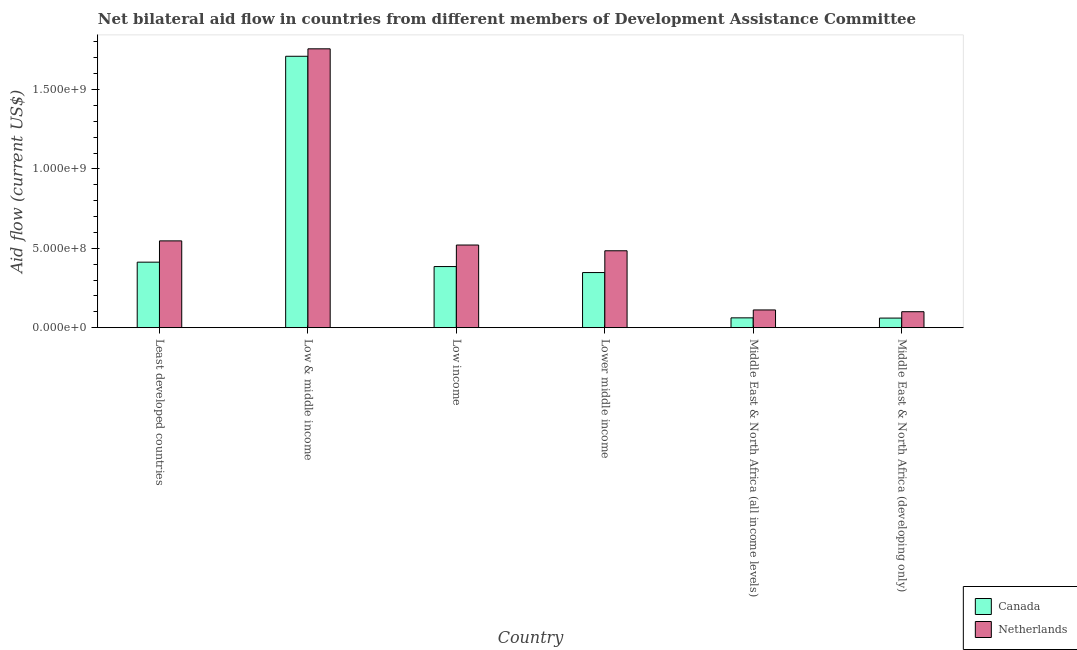How many different coloured bars are there?
Offer a very short reply. 2. Are the number of bars per tick equal to the number of legend labels?
Ensure brevity in your answer.  Yes. Are the number of bars on each tick of the X-axis equal?
Provide a short and direct response. Yes. What is the amount of aid given by netherlands in Low income?
Provide a succinct answer. 5.20e+08. Across all countries, what is the maximum amount of aid given by netherlands?
Your answer should be compact. 1.76e+09. Across all countries, what is the minimum amount of aid given by canada?
Offer a very short reply. 6.04e+07. In which country was the amount of aid given by canada maximum?
Make the answer very short. Low & middle income. In which country was the amount of aid given by netherlands minimum?
Make the answer very short. Middle East & North Africa (developing only). What is the total amount of aid given by canada in the graph?
Your response must be concise. 2.98e+09. What is the difference between the amount of aid given by canada in Least developed countries and that in Low & middle income?
Keep it short and to the point. -1.30e+09. What is the difference between the amount of aid given by netherlands in Low & middle income and the amount of aid given by canada in Middle East & North Africa (all income levels)?
Ensure brevity in your answer.  1.69e+09. What is the average amount of aid given by netherlands per country?
Your answer should be very brief. 5.87e+08. What is the difference between the amount of aid given by netherlands and amount of aid given by canada in Middle East & North Africa (all income levels)?
Your answer should be very brief. 4.98e+07. In how many countries, is the amount of aid given by canada greater than 1200000000 US$?
Your answer should be very brief. 1. What is the ratio of the amount of aid given by canada in Low income to that in Middle East & North Africa (all income levels)?
Give a very brief answer. 6.23. Is the amount of aid given by canada in Low & middle income less than that in Middle East & North Africa (all income levels)?
Provide a succinct answer. No. What is the difference between the highest and the second highest amount of aid given by canada?
Your answer should be compact. 1.30e+09. What is the difference between the highest and the lowest amount of aid given by canada?
Your response must be concise. 1.65e+09. In how many countries, is the amount of aid given by netherlands greater than the average amount of aid given by netherlands taken over all countries?
Your answer should be compact. 1. Is the sum of the amount of aid given by canada in Low income and Middle East & North Africa (all income levels) greater than the maximum amount of aid given by netherlands across all countries?
Provide a short and direct response. No. What does the 1st bar from the left in Least developed countries represents?
Provide a short and direct response. Canada. How many countries are there in the graph?
Provide a succinct answer. 6. What is the difference between two consecutive major ticks on the Y-axis?
Make the answer very short. 5.00e+08. Are the values on the major ticks of Y-axis written in scientific E-notation?
Make the answer very short. Yes. Does the graph contain any zero values?
Offer a very short reply. No. Where does the legend appear in the graph?
Offer a very short reply. Bottom right. What is the title of the graph?
Your answer should be very brief. Net bilateral aid flow in countries from different members of Development Assistance Committee. Does "Number of arrivals" appear as one of the legend labels in the graph?
Offer a terse response. No. What is the label or title of the X-axis?
Provide a succinct answer. Country. What is the label or title of the Y-axis?
Your answer should be compact. Aid flow (current US$). What is the Aid flow (current US$) in Canada in Least developed countries?
Your answer should be compact. 4.13e+08. What is the Aid flow (current US$) in Netherlands in Least developed countries?
Offer a very short reply. 5.47e+08. What is the Aid flow (current US$) of Canada in Low & middle income?
Ensure brevity in your answer.  1.71e+09. What is the Aid flow (current US$) in Netherlands in Low & middle income?
Your answer should be compact. 1.76e+09. What is the Aid flow (current US$) of Canada in Low income?
Ensure brevity in your answer.  3.85e+08. What is the Aid flow (current US$) of Netherlands in Low income?
Make the answer very short. 5.20e+08. What is the Aid flow (current US$) in Canada in Lower middle income?
Give a very brief answer. 3.47e+08. What is the Aid flow (current US$) in Netherlands in Lower middle income?
Provide a succinct answer. 4.84e+08. What is the Aid flow (current US$) in Canada in Middle East & North Africa (all income levels)?
Provide a short and direct response. 6.18e+07. What is the Aid flow (current US$) in Netherlands in Middle East & North Africa (all income levels)?
Give a very brief answer. 1.12e+08. What is the Aid flow (current US$) of Canada in Middle East & North Africa (developing only)?
Keep it short and to the point. 6.04e+07. What is the Aid flow (current US$) of Netherlands in Middle East & North Africa (developing only)?
Ensure brevity in your answer.  1.00e+08. Across all countries, what is the maximum Aid flow (current US$) in Canada?
Your answer should be very brief. 1.71e+09. Across all countries, what is the maximum Aid flow (current US$) in Netherlands?
Your answer should be very brief. 1.76e+09. Across all countries, what is the minimum Aid flow (current US$) of Canada?
Make the answer very short. 6.04e+07. Across all countries, what is the minimum Aid flow (current US$) of Netherlands?
Keep it short and to the point. 1.00e+08. What is the total Aid flow (current US$) of Canada in the graph?
Your answer should be compact. 2.98e+09. What is the total Aid flow (current US$) of Netherlands in the graph?
Your answer should be very brief. 3.52e+09. What is the difference between the Aid flow (current US$) of Canada in Least developed countries and that in Low & middle income?
Provide a succinct answer. -1.30e+09. What is the difference between the Aid flow (current US$) of Netherlands in Least developed countries and that in Low & middle income?
Your answer should be very brief. -1.21e+09. What is the difference between the Aid flow (current US$) of Canada in Least developed countries and that in Low income?
Offer a terse response. 2.77e+07. What is the difference between the Aid flow (current US$) in Netherlands in Least developed countries and that in Low income?
Offer a terse response. 2.61e+07. What is the difference between the Aid flow (current US$) of Canada in Least developed countries and that in Lower middle income?
Provide a succinct answer. 6.55e+07. What is the difference between the Aid flow (current US$) in Netherlands in Least developed countries and that in Lower middle income?
Your answer should be compact. 6.23e+07. What is the difference between the Aid flow (current US$) in Canada in Least developed countries and that in Middle East & North Africa (all income levels)?
Your answer should be compact. 3.51e+08. What is the difference between the Aid flow (current US$) in Netherlands in Least developed countries and that in Middle East & North Africa (all income levels)?
Provide a short and direct response. 4.35e+08. What is the difference between the Aid flow (current US$) in Canada in Least developed countries and that in Middle East & North Africa (developing only)?
Keep it short and to the point. 3.52e+08. What is the difference between the Aid flow (current US$) of Netherlands in Least developed countries and that in Middle East & North Africa (developing only)?
Give a very brief answer. 4.46e+08. What is the difference between the Aid flow (current US$) in Canada in Low & middle income and that in Low income?
Provide a succinct answer. 1.32e+09. What is the difference between the Aid flow (current US$) in Netherlands in Low & middle income and that in Low income?
Your answer should be compact. 1.24e+09. What is the difference between the Aid flow (current US$) of Canada in Low & middle income and that in Lower middle income?
Your response must be concise. 1.36e+09. What is the difference between the Aid flow (current US$) in Netherlands in Low & middle income and that in Lower middle income?
Provide a short and direct response. 1.27e+09. What is the difference between the Aid flow (current US$) of Canada in Low & middle income and that in Middle East & North Africa (all income levels)?
Your answer should be very brief. 1.65e+09. What is the difference between the Aid flow (current US$) of Netherlands in Low & middle income and that in Middle East & North Africa (all income levels)?
Keep it short and to the point. 1.64e+09. What is the difference between the Aid flow (current US$) in Canada in Low & middle income and that in Middle East & North Africa (developing only)?
Offer a very short reply. 1.65e+09. What is the difference between the Aid flow (current US$) in Netherlands in Low & middle income and that in Middle East & North Africa (developing only)?
Provide a succinct answer. 1.66e+09. What is the difference between the Aid flow (current US$) in Canada in Low income and that in Lower middle income?
Your response must be concise. 3.78e+07. What is the difference between the Aid flow (current US$) in Netherlands in Low income and that in Lower middle income?
Ensure brevity in your answer.  3.61e+07. What is the difference between the Aid flow (current US$) of Canada in Low income and that in Middle East & North Africa (all income levels)?
Offer a very short reply. 3.23e+08. What is the difference between the Aid flow (current US$) in Netherlands in Low income and that in Middle East & North Africa (all income levels)?
Offer a very short reply. 4.09e+08. What is the difference between the Aid flow (current US$) of Canada in Low income and that in Middle East & North Africa (developing only)?
Keep it short and to the point. 3.25e+08. What is the difference between the Aid flow (current US$) of Netherlands in Low income and that in Middle East & North Africa (developing only)?
Offer a very short reply. 4.20e+08. What is the difference between the Aid flow (current US$) in Canada in Lower middle income and that in Middle East & North Africa (all income levels)?
Your response must be concise. 2.85e+08. What is the difference between the Aid flow (current US$) in Netherlands in Lower middle income and that in Middle East & North Africa (all income levels)?
Offer a very short reply. 3.73e+08. What is the difference between the Aid flow (current US$) of Canada in Lower middle income and that in Middle East & North Africa (developing only)?
Give a very brief answer. 2.87e+08. What is the difference between the Aid flow (current US$) of Netherlands in Lower middle income and that in Middle East & North Africa (developing only)?
Offer a very short reply. 3.84e+08. What is the difference between the Aid flow (current US$) of Canada in Middle East & North Africa (all income levels) and that in Middle East & North Africa (developing only)?
Your response must be concise. 1.44e+06. What is the difference between the Aid flow (current US$) of Netherlands in Middle East & North Africa (all income levels) and that in Middle East & North Africa (developing only)?
Provide a succinct answer. 1.12e+07. What is the difference between the Aid flow (current US$) of Canada in Least developed countries and the Aid flow (current US$) of Netherlands in Low & middle income?
Your answer should be compact. -1.34e+09. What is the difference between the Aid flow (current US$) of Canada in Least developed countries and the Aid flow (current US$) of Netherlands in Low income?
Your answer should be compact. -1.08e+08. What is the difference between the Aid flow (current US$) in Canada in Least developed countries and the Aid flow (current US$) in Netherlands in Lower middle income?
Give a very brief answer. -7.17e+07. What is the difference between the Aid flow (current US$) of Canada in Least developed countries and the Aid flow (current US$) of Netherlands in Middle East & North Africa (all income levels)?
Your response must be concise. 3.01e+08. What is the difference between the Aid flow (current US$) of Canada in Least developed countries and the Aid flow (current US$) of Netherlands in Middle East & North Africa (developing only)?
Ensure brevity in your answer.  3.12e+08. What is the difference between the Aid flow (current US$) of Canada in Low & middle income and the Aid flow (current US$) of Netherlands in Low income?
Keep it short and to the point. 1.19e+09. What is the difference between the Aid flow (current US$) in Canada in Low & middle income and the Aid flow (current US$) in Netherlands in Lower middle income?
Your response must be concise. 1.22e+09. What is the difference between the Aid flow (current US$) of Canada in Low & middle income and the Aid flow (current US$) of Netherlands in Middle East & North Africa (all income levels)?
Keep it short and to the point. 1.60e+09. What is the difference between the Aid flow (current US$) of Canada in Low & middle income and the Aid flow (current US$) of Netherlands in Middle East & North Africa (developing only)?
Give a very brief answer. 1.61e+09. What is the difference between the Aid flow (current US$) of Canada in Low income and the Aid flow (current US$) of Netherlands in Lower middle income?
Your response must be concise. -9.94e+07. What is the difference between the Aid flow (current US$) in Canada in Low income and the Aid flow (current US$) in Netherlands in Middle East & North Africa (all income levels)?
Make the answer very short. 2.73e+08. What is the difference between the Aid flow (current US$) of Canada in Low income and the Aid flow (current US$) of Netherlands in Middle East & North Africa (developing only)?
Offer a terse response. 2.84e+08. What is the difference between the Aid flow (current US$) of Canada in Lower middle income and the Aid flow (current US$) of Netherlands in Middle East & North Africa (all income levels)?
Ensure brevity in your answer.  2.35e+08. What is the difference between the Aid flow (current US$) of Canada in Lower middle income and the Aid flow (current US$) of Netherlands in Middle East & North Africa (developing only)?
Your response must be concise. 2.47e+08. What is the difference between the Aid flow (current US$) of Canada in Middle East & North Africa (all income levels) and the Aid flow (current US$) of Netherlands in Middle East & North Africa (developing only)?
Ensure brevity in your answer.  -3.86e+07. What is the average Aid flow (current US$) of Canada per country?
Your response must be concise. 4.96e+08. What is the average Aid flow (current US$) in Netherlands per country?
Give a very brief answer. 5.87e+08. What is the difference between the Aid flow (current US$) in Canada and Aid flow (current US$) in Netherlands in Least developed countries?
Your response must be concise. -1.34e+08. What is the difference between the Aid flow (current US$) in Canada and Aid flow (current US$) in Netherlands in Low & middle income?
Ensure brevity in your answer.  -4.70e+07. What is the difference between the Aid flow (current US$) in Canada and Aid flow (current US$) in Netherlands in Low income?
Your answer should be very brief. -1.36e+08. What is the difference between the Aid flow (current US$) in Canada and Aid flow (current US$) in Netherlands in Lower middle income?
Your answer should be very brief. -1.37e+08. What is the difference between the Aid flow (current US$) of Canada and Aid flow (current US$) of Netherlands in Middle East & North Africa (all income levels)?
Give a very brief answer. -4.98e+07. What is the difference between the Aid flow (current US$) of Canada and Aid flow (current US$) of Netherlands in Middle East & North Africa (developing only)?
Your answer should be very brief. -4.01e+07. What is the ratio of the Aid flow (current US$) in Canada in Least developed countries to that in Low & middle income?
Your answer should be very brief. 0.24. What is the ratio of the Aid flow (current US$) in Netherlands in Least developed countries to that in Low & middle income?
Your answer should be very brief. 0.31. What is the ratio of the Aid flow (current US$) in Canada in Least developed countries to that in Low income?
Provide a short and direct response. 1.07. What is the ratio of the Aid flow (current US$) of Netherlands in Least developed countries to that in Low income?
Keep it short and to the point. 1.05. What is the ratio of the Aid flow (current US$) of Canada in Least developed countries to that in Lower middle income?
Keep it short and to the point. 1.19. What is the ratio of the Aid flow (current US$) in Netherlands in Least developed countries to that in Lower middle income?
Your answer should be very brief. 1.13. What is the ratio of the Aid flow (current US$) in Canada in Least developed countries to that in Middle East & North Africa (all income levels)?
Your answer should be compact. 6.68. What is the ratio of the Aid flow (current US$) of Netherlands in Least developed countries to that in Middle East & North Africa (all income levels)?
Offer a terse response. 4.9. What is the ratio of the Aid flow (current US$) of Canada in Least developed countries to that in Middle East & North Africa (developing only)?
Offer a very short reply. 6.84. What is the ratio of the Aid flow (current US$) of Netherlands in Least developed countries to that in Middle East & North Africa (developing only)?
Your response must be concise. 5.44. What is the ratio of the Aid flow (current US$) of Canada in Low & middle income to that in Low income?
Ensure brevity in your answer.  4.44. What is the ratio of the Aid flow (current US$) in Netherlands in Low & middle income to that in Low income?
Your answer should be compact. 3.37. What is the ratio of the Aid flow (current US$) in Canada in Low & middle income to that in Lower middle income?
Offer a terse response. 4.92. What is the ratio of the Aid flow (current US$) of Netherlands in Low & middle income to that in Lower middle income?
Keep it short and to the point. 3.63. What is the ratio of the Aid flow (current US$) of Canada in Low & middle income to that in Middle East & North Africa (all income levels)?
Give a very brief answer. 27.66. What is the ratio of the Aid flow (current US$) in Netherlands in Low & middle income to that in Middle East & North Africa (all income levels)?
Give a very brief answer. 15.73. What is the ratio of the Aid flow (current US$) in Canada in Low & middle income to that in Middle East & North Africa (developing only)?
Your response must be concise. 28.32. What is the ratio of the Aid flow (current US$) in Netherlands in Low & middle income to that in Middle East & North Africa (developing only)?
Your answer should be very brief. 17.49. What is the ratio of the Aid flow (current US$) of Canada in Low income to that in Lower middle income?
Provide a short and direct response. 1.11. What is the ratio of the Aid flow (current US$) in Netherlands in Low income to that in Lower middle income?
Give a very brief answer. 1.07. What is the ratio of the Aid flow (current US$) in Canada in Low income to that in Middle East & North Africa (all income levels)?
Offer a very short reply. 6.23. What is the ratio of the Aid flow (current US$) in Netherlands in Low income to that in Middle East & North Africa (all income levels)?
Ensure brevity in your answer.  4.66. What is the ratio of the Aid flow (current US$) in Canada in Low income to that in Middle East & North Africa (developing only)?
Ensure brevity in your answer.  6.38. What is the ratio of the Aid flow (current US$) of Netherlands in Low income to that in Middle East & North Africa (developing only)?
Keep it short and to the point. 5.18. What is the ratio of the Aid flow (current US$) of Canada in Lower middle income to that in Middle East & North Africa (all income levels)?
Give a very brief answer. 5.62. What is the ratio of the Aid flow (current US$) in Netherlands in Lower middle income to that in Middle East & North Africa (all income levels)?
Ensure brevity in your answer.  4.34. What is the ratio of the Aid flow (current US$) of Canada in Lower middle income to that in Middle East & North Africa (developing only)?
Give a very brief answer. 5.75. What is the ratio of the Aid flow (current US$) of Netherlands in Lower middle income to that in Middle East & North Africa (developing only)?
Your answer should be very brief. 4.82. What is the ratio of the Aid flow (current US$) in Canada in Middle East & North Africa (all income levels) to that in Middle East & North Africa (developing only)?
Offer a very short reply. 1.02. What is the ratio of the Aid flow (current US$) in Netherlands in Middle East & North Africa (all income levels) to that in Middle East & North Africa (developing only)?
Give a very brief answer. 1.11. What is the difference between the highest and the second highest Aid flow (current US$) in Canada?
Offer a very short reply. 1.30e+09. What is the difference between the highest and the second highest Aid flow (current US$) of Netherlands?
Keep it short and to the point. 1.21e+09. What is the difference between the highest and the lowest Aid flow (current US$) in Canada?
Make the answer very short. 1.65e+09. What is the difference between the highest and the lowest Aid flow (current US$) in Netherlands?
Ensure brevity in your answer.  1.66e+09. 